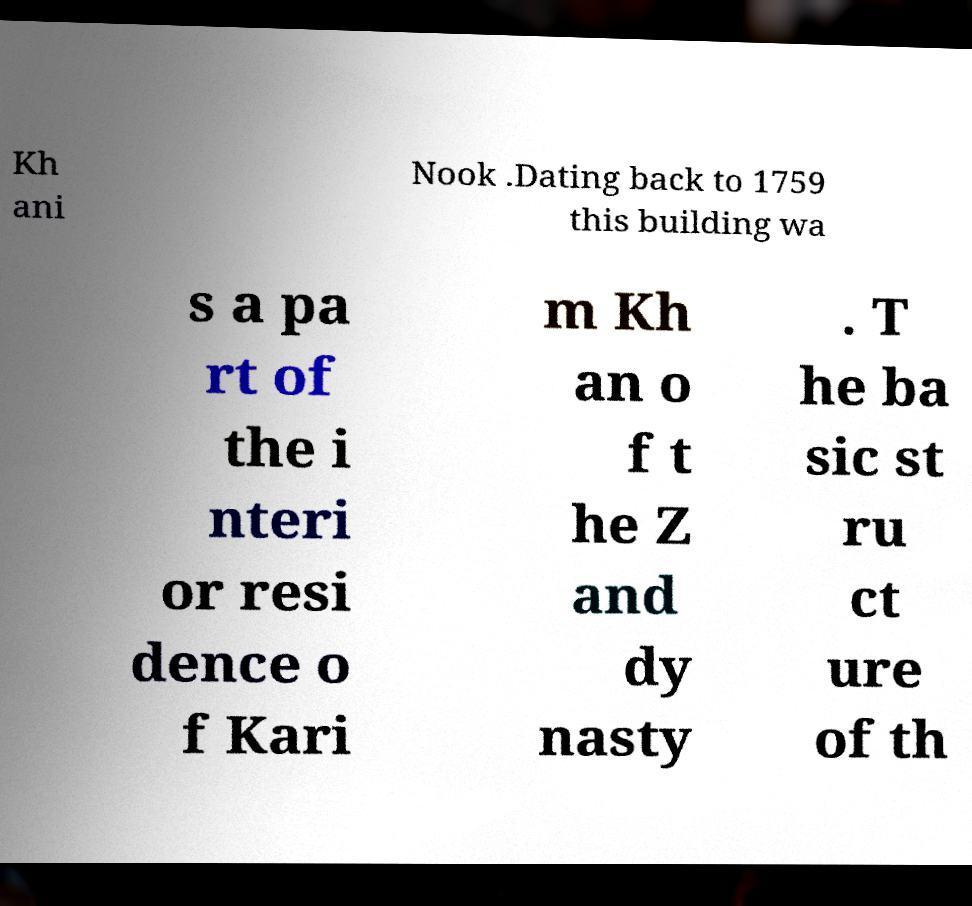What messages or text are displayed in this image? I need them in a readable, typed format. Kh ani Nook .Dating back to 1759 this building wa s a pa rt of the i nteri or resi dence o f Kari m Kh an o f t he Z and dy nasty . T he ba sic st ru ct ure of th 